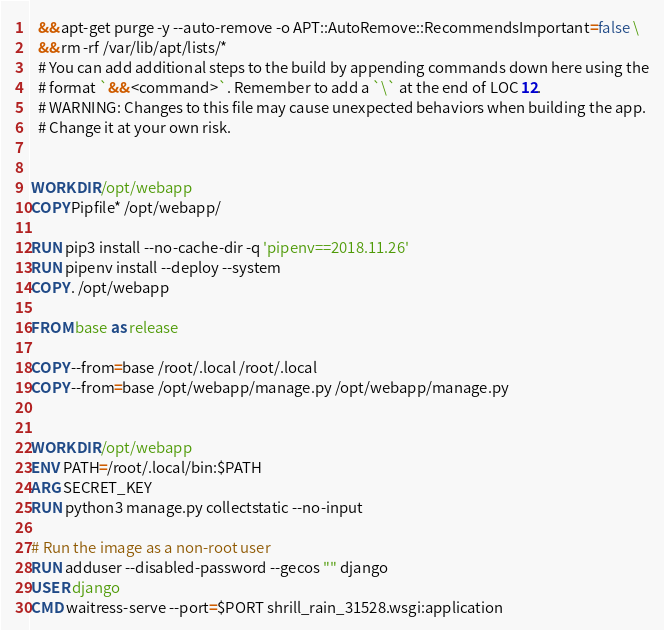Convert code to text. <code><loc_0><loc_0><loc_500><loc_500><_Dockerfile_>  && apt-get purge -y --auto-remove -o APT::AutoRemove::RecommendsImportant=false \
  && rm -rf /var/lib/apt/lists/*
  # You can add additional steps to the build by appending commands down here using the
  # format `&& <command>`. Remember to add a `\` at the end of LOC 12.
  # WARNING: Changes to this file may cause unexpected behaviors when building the app.
  # Change it at your own risk.


WORKDIR /opt/webapp
COPY Pipfile* /opt/webapp/

RUN pip3 install --no-cache-dir -q 'pipenv==2018.11.26' 
RUN pipenv install --deploy --system
COPY . /opt/webapp

FROM base as release

COPY --from=base /root/.local /root/.local
COPY --from=base /opt/webapp/manage.py /opt/webapp/manage.py


WORKDIR /opt/webapp
ENV PATH=/root/.local/bin:$PATH
ARG SECRET_KEY 
RUN python3 manage.py collectstatic --no-input

# Run the image as a non-root user
RUN adduser --disabled-password --gecos "" django
USER django
CMD waitress-serve --port=$PORT shrill_rain_31528.wsgi:application
</code> 